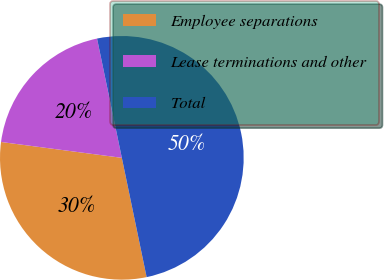Convert chart. <chart><loc_0><loc_0><loc_500><loc_500><pie_chart><fcel>Employee separations<fcel>Lease terminations and other<fcel>Total<nl><fcel>30.34%<fcel>19.66%<fcel>50.0%<nl></chart> 